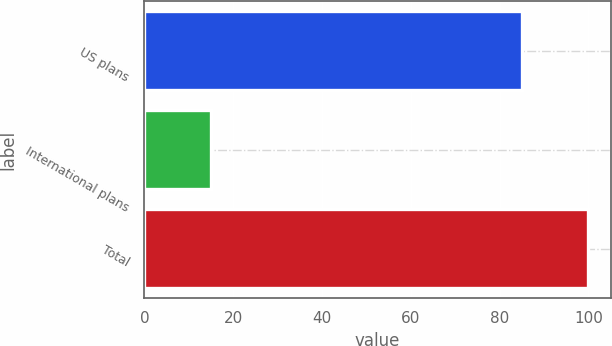Convert chart. <chart><loc_0><loc_0><loc_500><loc_500><bar_chart><fcel>US plans<fcel>International plans<fcel>Total<nl><fcel>85<fcel>15<fcel>100<nl></chart> 